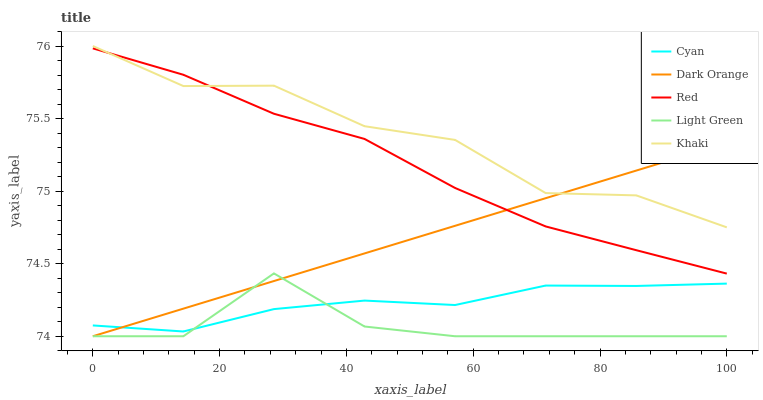Does Light Green have the minimum area under the curve?
Answer yes or no. Yes. Does Khaki have the maximum area under the curve?
Answer yes or no. Yes. Does Khaki have the minimum area under the curve?
Answer yes or no. No. Does Light Green have the maximum area under the curve?
Answer yes or no. No. Is Dark Orange the smoothest?
Answer yes or no. Yes. Is Light Green the roughest?
Answer yes or no. Yes. Is Khaki the smoothest?
Answer yes or no. No. Is Khaki the roughest?
Answer yes or no. No. Does Light Green have the lowest value?
Answer yes or no. Yes. Does Khaki have the lowest value?
Answer yes or no. No. Does Khaki have the highest value?
Answer yes or no. Yes. Does Light Green have the highest value?
Answer yes or no. No. Is Light Green less than Red?
Answer yes or no. Yes. Is Red greater than Light Green?
Answer yes or no. Yes. Does Khaki intersect Dark Orange?
Answer yes or no. Yes. Is Khaki less than Dark Orange?
Answer yes or no. No. Is Khaki greater than Dark Orange?
Answer yes or no. No. Does Light Green intersect Red?
Answer yes or no. No. 